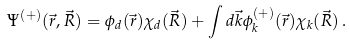<formula> <loc_0><loc_0><loc_500><loc_500>\Psi ^ { ( + ) } ( \vec { r } , \vec { R } ) = \phi _ { d } ( \vec { r } ) \chi _ { d } ( \vec { R } ) + \int d \vec { k } \phi ^ { ( + ) } _ { k } ( \vec { r } ) \chi _ { k } ( \vec { R } ) \, .</formula> 